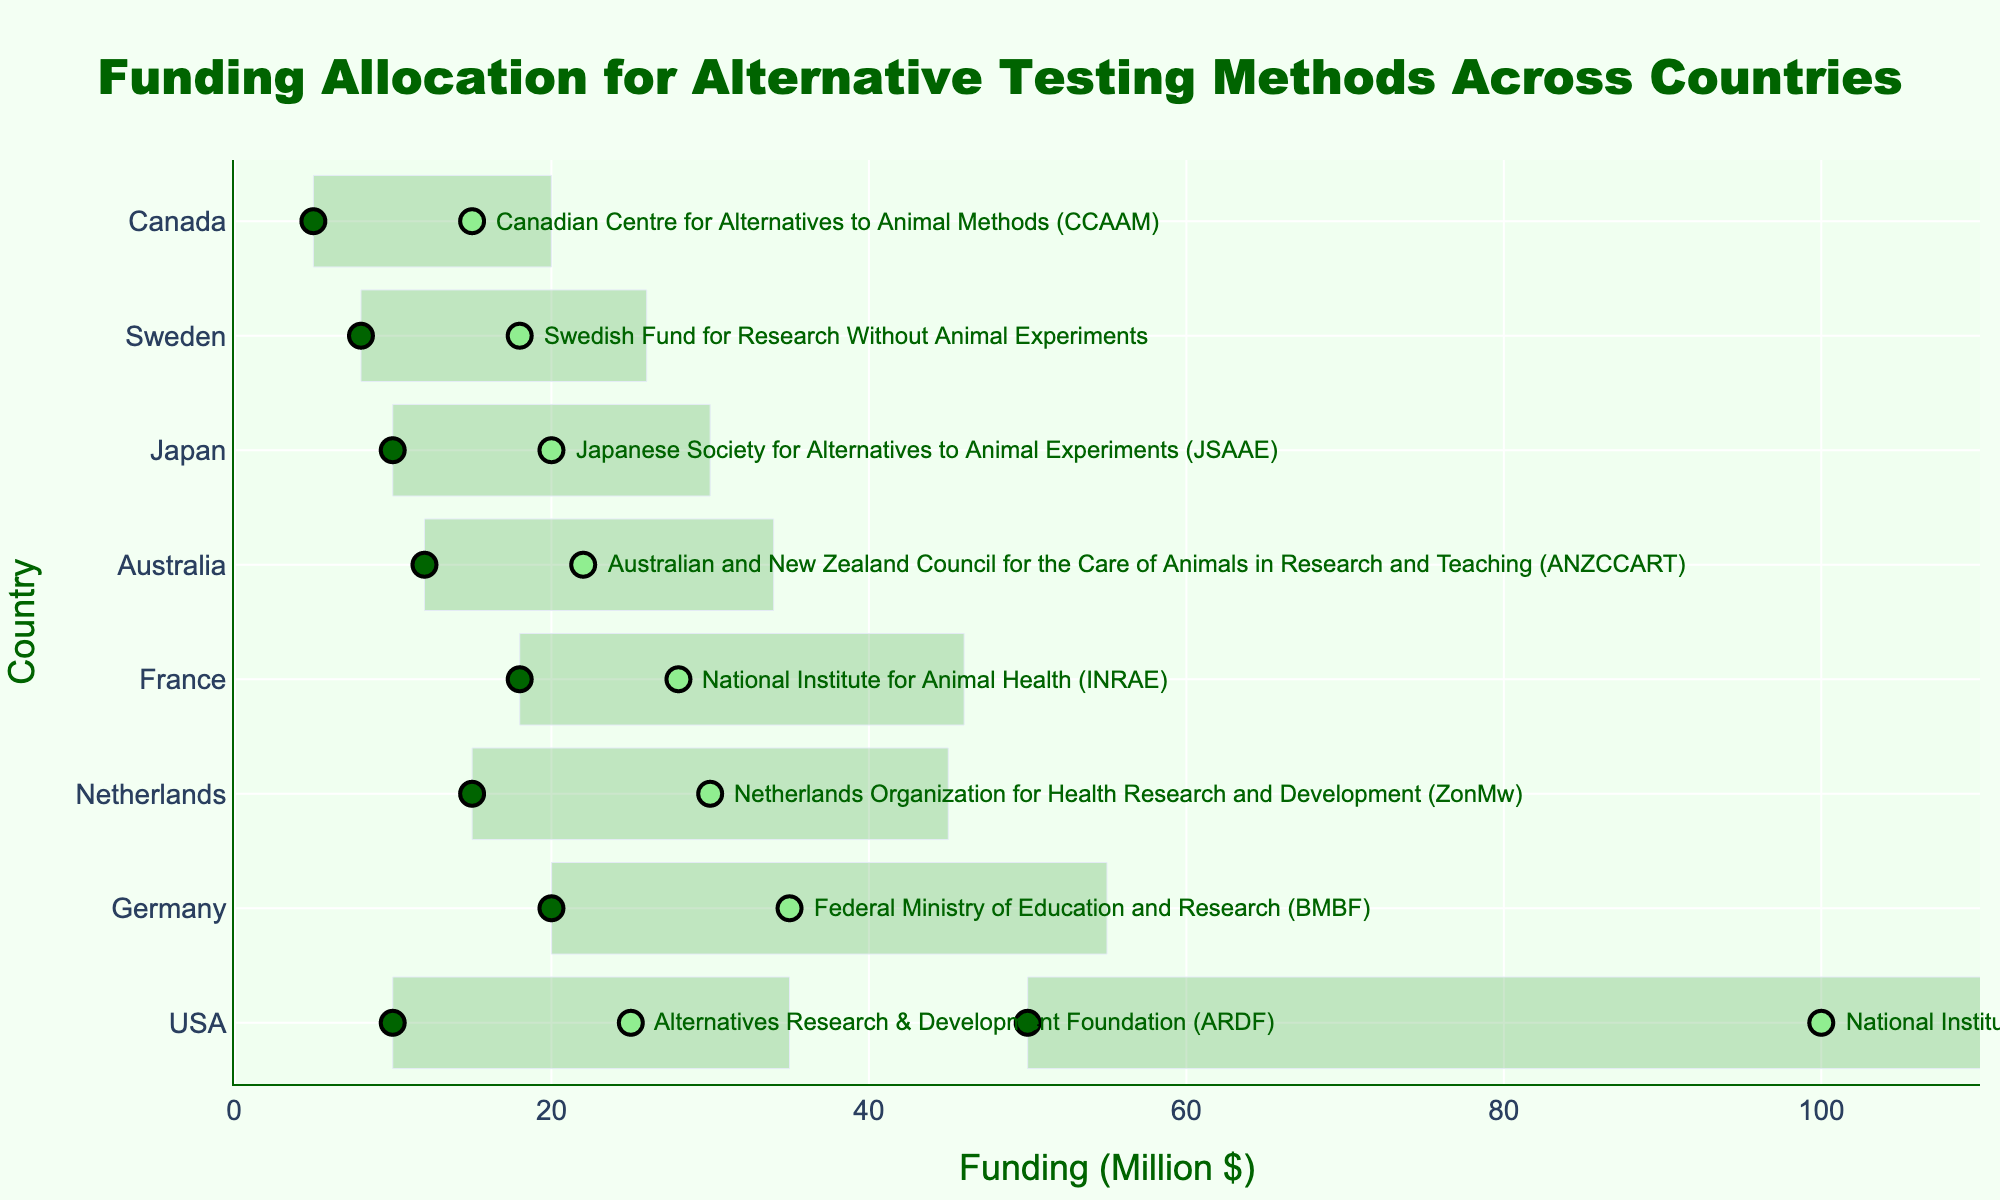Which country has the highest maximum funding allocation for alternative testing methods? The figure shows various countries on the y-axis with their funding ranges, and the USA has the highest bar extending to 100 million dollars for the National Institute of Health (NIH).
Answer: USA What's the total funding range for the Swedish organization? The Swedish organization’s funding range extends from 8 million dollars (minimum) to 18 million dollars (maximum). Calculating the range: 18 - 8 = 10.
Answer: 10 million dollars How many organizations have a maximum funding allocation greater than 30 million dollars? Referring to the data on the figure, only two organizations (from the USA with NIH [100 million dollars] and from Germany with BMBF [35 million dollars]) have maximum funding allocations greater than 30 million dollars.
Answer: 2 Which country's organization has the smallest minimum funding allocation, and what is that amount? From the plot, the Canadian organization (CCAAM) has the smallest minimum funding allocation, which is 5 million dollars.
Answer: Canada, 5 million dollars What is the difference in maximum funding allocation between the Australian and the German organizations? The figure shows that the German organization (BMBF) has a maximum funding of 35 million dollars, and the Australian organization (ANZCCART) has 22 million dollars. The difference is 35 - 22 = 13.
Answer: 13 million dollars Which organization in the plot has the smallest range of funding allocation? The Japanese Society for Alternatives to Animal Experiments (JSAAE) has a range of 10 to 20 million dollars, which is 20 - 10 = 10 million dollars, tied as the smallest range with the Swedish organization.
Answer: JSAAE and Swedish Fund for Research Without Animal Experiments What's the average maximum funding allocation among the organizations from the USA? The two organizations from the USA have maximum funding of 100 (NIH) and 25 (ARDF) million dollars. The average is (100 + 25) / 2 = 62.5.
Answer: 62.5 million dollars 